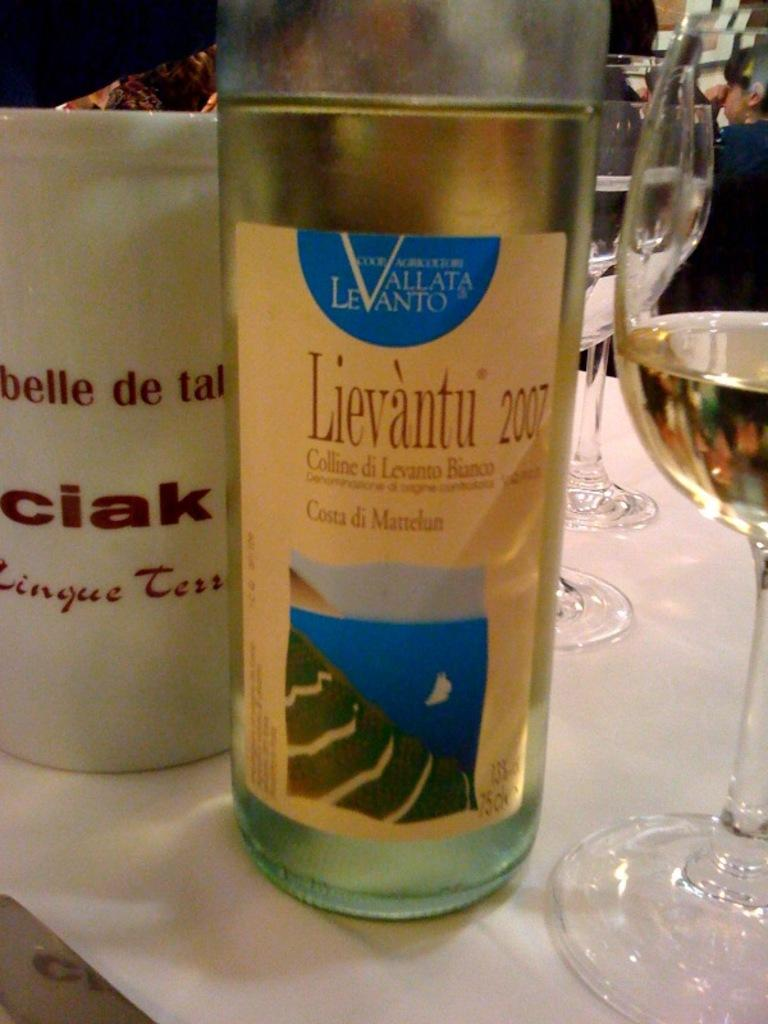<image>
Offer a succinct explanation of the picture presented. the year 2007 is on a wine bottle 